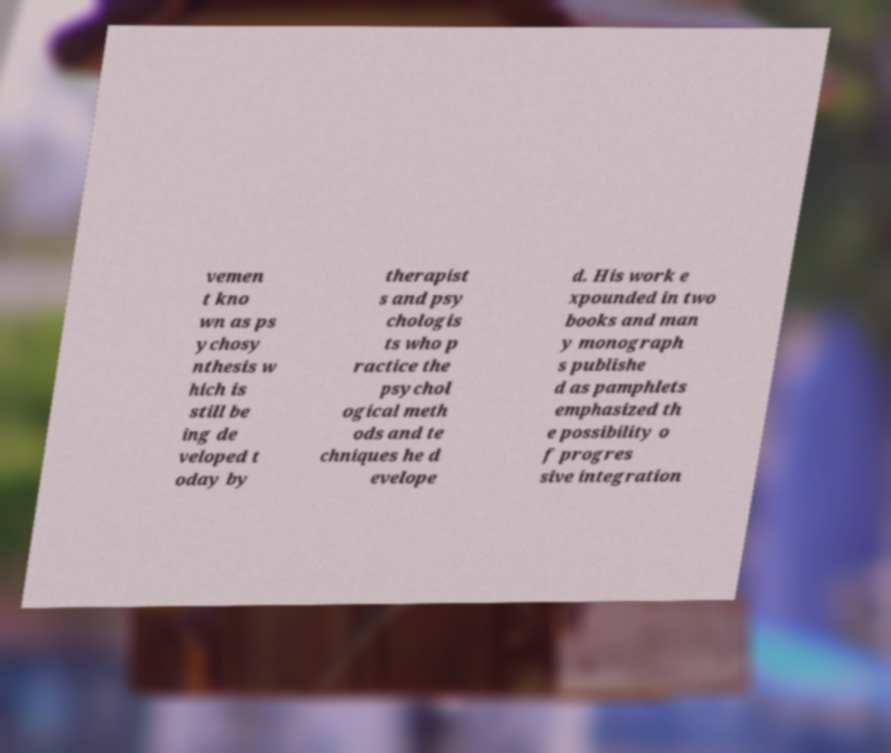There's text embedded in this image that I need extracted. Can you transcribe it verbatim? vemen t kno wn as ps ychosy nthesis w hich is still be ing de veloped t oday by therapist s and psy chologis ts who p ractice the psychol ogical meth ods and te chniques he d evelope d. His work e xpounded in two books and man y monograph s publishe d as pamphlets emphasized th e possibility o f progres sive integration 